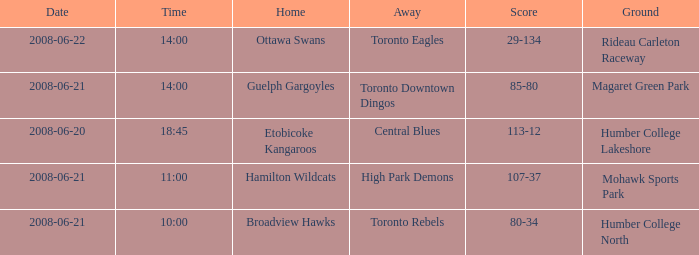What is the Time with a Score that is 80-34? 10:00. 